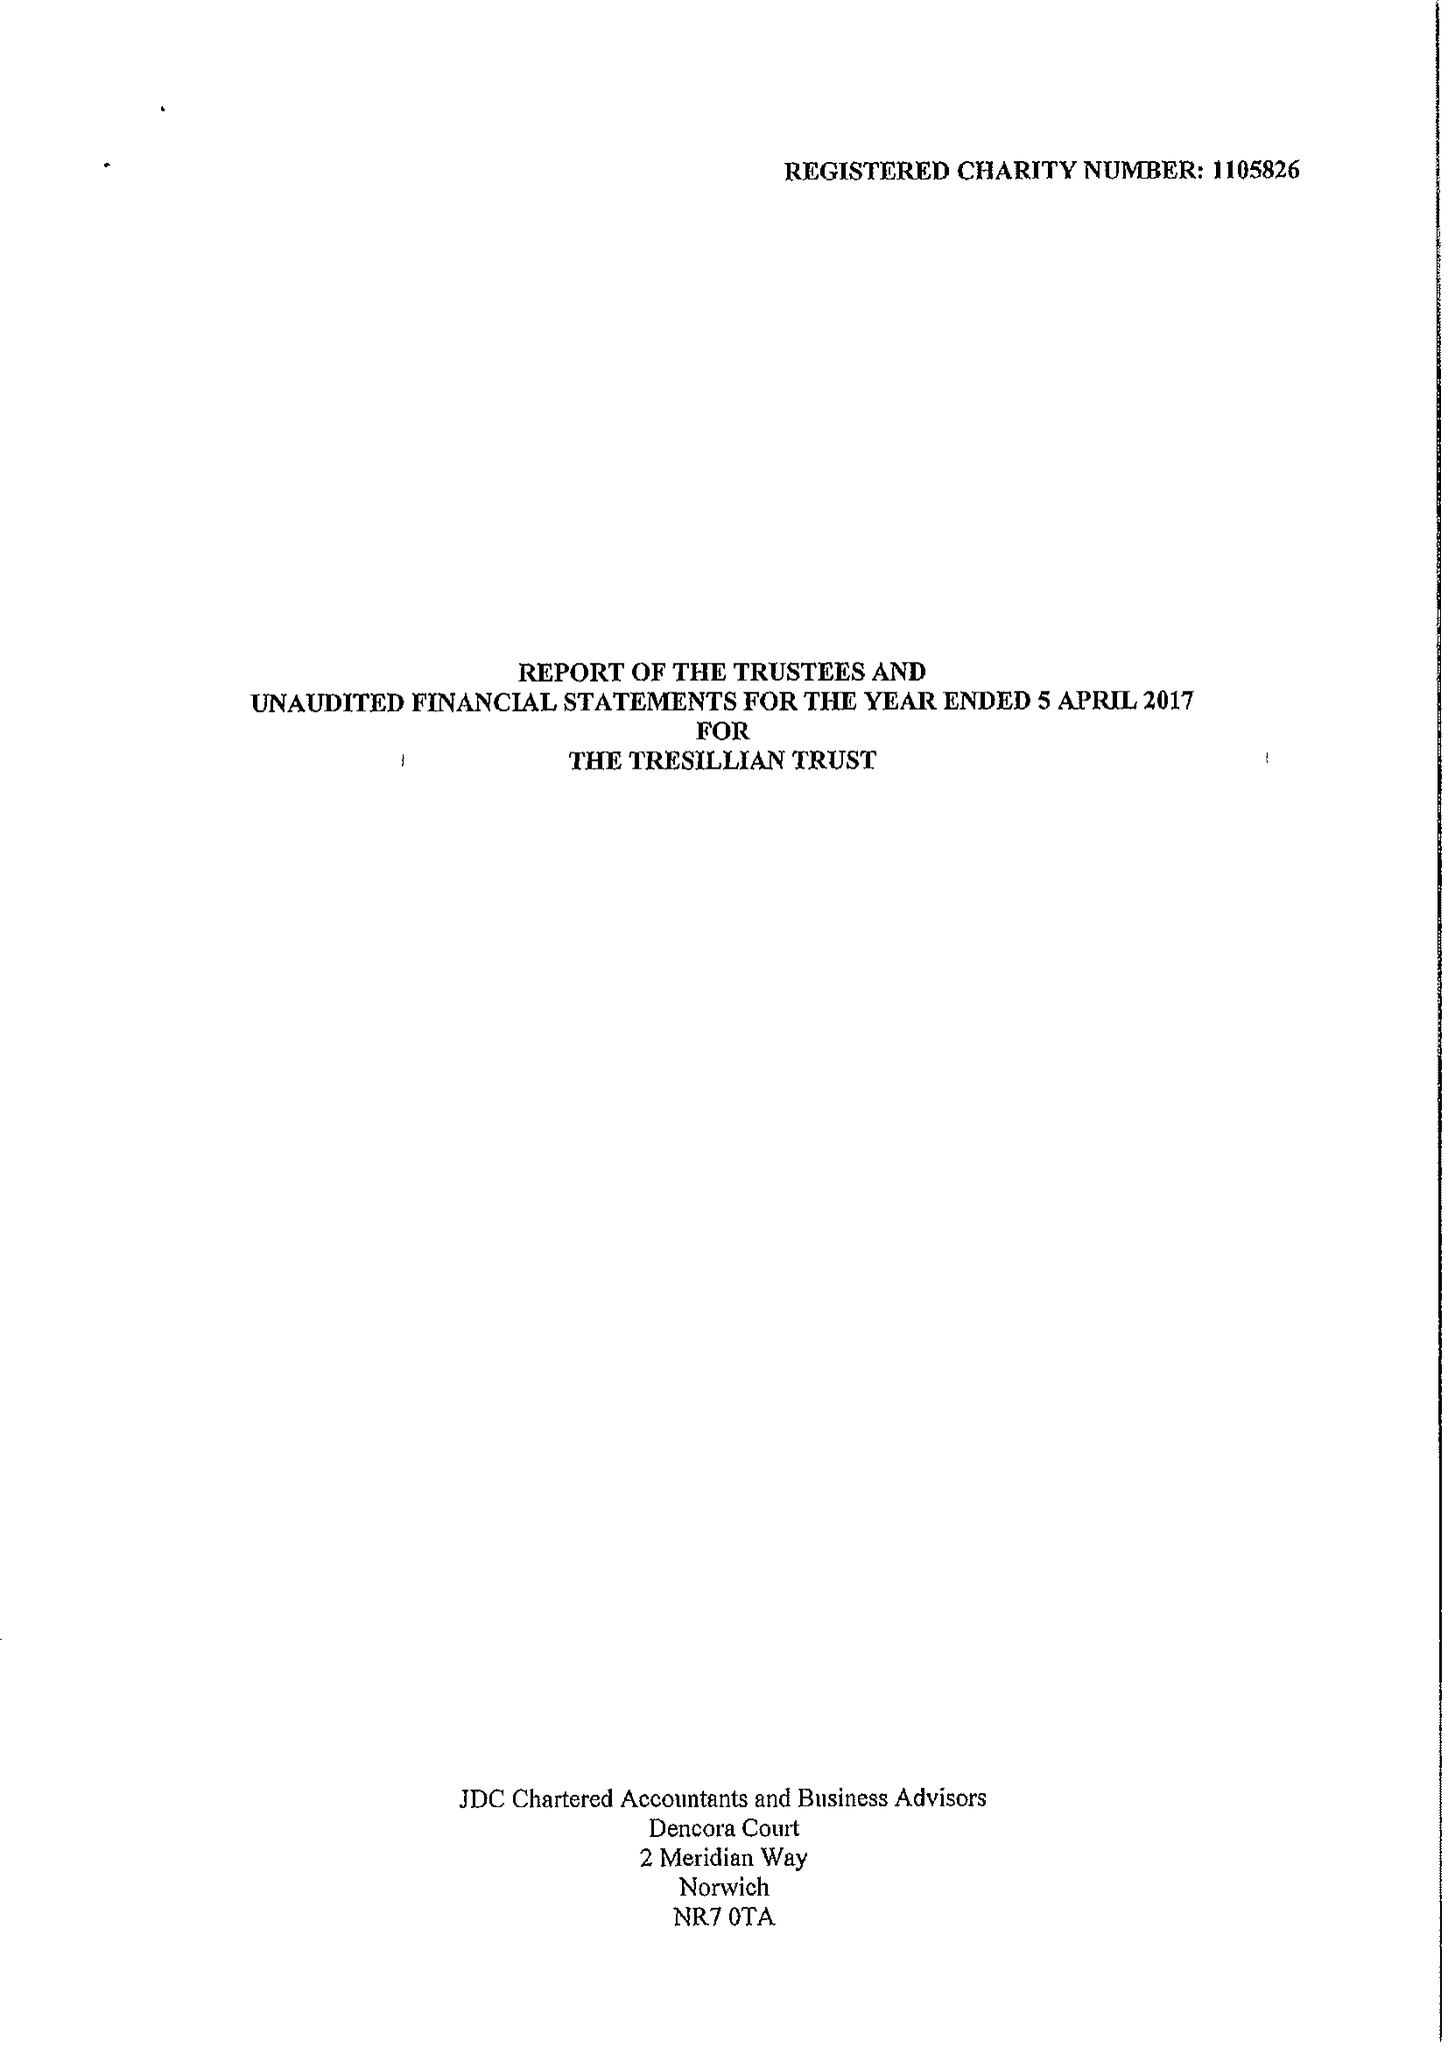What is the value for the spending_annually_in_british_pounds?
Answer the question using a single word or phrase. 22313.00 